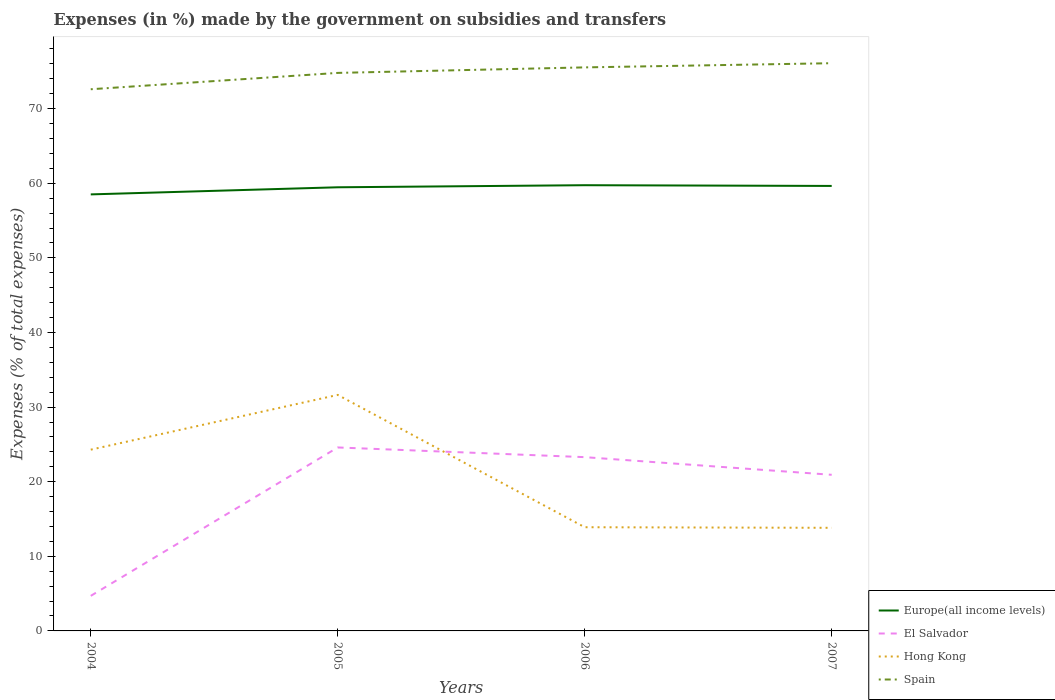How many different coloured lines are there?
Your response must be concise. 4. Is the number of lines equal to the number of legend labels?
Ensure brevity in your answer.  Yes. Across all years, what is the maximum percentage of expenses made by the government on subsidies and transfers in Spain?
Make the answer very short. 72.6. In which year was the percentage of expenses made by the government on subsidies and transfers in Spain maximum?
Your answer should be compact. 2004. What is the total percentage of expenses made by the government on subsidies and transfers in Europe(all income levels) in the graph?
Your answer should be very brief. -1.23. What is the difference between the highest and the second highest percentage of expenses made by the government on subsidies and transfers in Hong Kong?
Your answer should be very brief. 17.81. What is the difference between the highest and the lowest percentage of expenses made by the government on subsidies and transfers in Europe(all income levels)?
Your answer should be compact. 3. Is the percentage of expenses made by the government on subsidies and transfers in Spain strictly greater than the percentage of expenses made by the government on subsidies and transfers in El Salvador over the years?
Keep it short and to the point. No. How many lines are there?
Ensure brevity in your answer.  4. How many years are there in the graph?
Offer a terse response. 4. Are the values on the major ticks of Y-axis written in scientific E-notation?
Your answer should be compact. No. Does the graph contain grids?
Offer a very short reply. No. Where does the legend appear in the graph?
Your response must be concise. Bottom right. How many legend labels are there?
Provide a succinct answer. 4. How are the legend labels stacked?
Keep it short and to the point. Vertical. What is the title of the graph?
Ensure brevity in your answer.  Expenses (in %) made by the government on subsidies and transfers. What is the label or title of the X-axis?
Keep it short and to the point. Years. What is the label or title of the Y-axis?
Offer a terse response. Expenses (% of total expenses). What is the Expenses (% of total expenses) in Europe(all income levels) in 2004?
Your response must be concise. 58.5. What is the Expenses (% of total expenses) in El Salvador in 2004?
Ensure brevity in your answer.  4.7. What is the Expenses (% of total expenses) in Hong Kong in 2004?
Ensure brevity in your answer.  24.29. What is the Expenses (% of total expenses) in Spain in 2004?
Make the answer very short. 72.6. What is the Expenses (% of total expenses) in Europe(all income levels) in 2005?
Provide a succinct answer. 59.46. What is the Expenses (% of total expenses) in El Salvador in 2005?
Give a very brief answer. 24.59. What is the Expenses (% of total expenses) in Hong Kong in 2005?
Your answer should be compact. 31.63. What is the Expenses (% of total expenses) in Spain in 2005?
Provide a succinct answer. 74.79. What is the Expenses (% of total expenses) in Europe(all income levels) in 2006?
Your answer should be very brief. 59.74. What is the Expenses (% of total expenses) of El Salvador in 2006?
Provide a short and direct response. 23.29. What is the Expenses (% of total expenses) in Hong Kong in 2006?
Give a very brief answer. 13.9. What is the Expenses (% of total expenses) in Spain in 2006?
Ensure brevity in your answer.  75.53. What is the Expenses (% of total expenses) of Europe(all income levels) in 2007?
Provide a short and direct response. 59.64. What is the Expenses (% of total expenses) of El Salvador in 2007?
Your answer should be compact. 20.92. What is the Expenses (% of total expenses) in Hong Kong in 2007?
Your answer should be compact. 13.82. What is the Expenses (% of total expenses) of Spain in 2007?
Give a very brief answer. 76.09. Across all years, what is the maximum Expenses (% of total expenses) of Europe(all income levels)?
Keep it short and to the point. 59.74. Across all years, what is the maximum Expenses (% of total expenses) of El Salvador?
Provide a succinct answer. 24.59. Across all years, what is the maximum Expenses (% of total expenses) of Hong Kong?
Give a very brief answer. 31.63. Across all years, what is the maximum Expenses (% of total expenses) in Spain?
Ensure brevity in your answer.  76.09. Across all years, what is the minimum Expenses (% of total expenses) of Europe(all income levels)?
Your answer should be compact. 58.5. Across all years, what is the minimum Expenses (% of total expenses) of El Salvador?
Provide a succinct answer. 4.7. Across all years, what is the minimum Expenses (% of total expenses) of Hong Kong?
Ensure brevity in your answer.  13.82. Across all years, what is the minimum Expenses (% of total expenses) of Spain?
Your response must be concise. 72.6. What is the total Expenses (% of total expenses) in Europe(all income levels) in the graph?
Make the answer very short. 237.34. What is the total Expenses (% of total expenses) in El Salvador in the graph?
Your answer should be very brief. 73.5. What is the total Expenses (% of total expenses) of Hong Kong in the graph?
Offer a very short reply. 83.64. What is the total Expenses (% of total expenses) of Spain in the graph?
Make the answer very short. 299. What is the difference between the Expenses (% of total expenses) in Europe(all income levels) in 2004 and that in 2005?
Make the answer very short. -0.95. What is the difference between the Expenses (% of total expenses) in El Salvador in 2004 and that in 2005?
Ensure brevity in your answer.  -19.89. What is the difference between the Expenses (% of total expenses) of Hong Kong in 2004 and that in 2005?
Your response must be concise. -7.34. What is the difference between the Expenses (% of total expenses) in Spain in 2004 and that in 2005?
Offer a very short reply. -2.19. What is the difference between the Expenses (% of total expenses) of Europe(all income levels) in 2004 and that in 2006?
Your answer should be compact. -1.23. What is the difference between the Expenses (% of total expenses) in El Salvador in 2004 and that in 2006?
Make the answer very short. -18.59. What is the difference between the Expenses (% of total expenses) in Hong Kong in 2004 and that in 2006?
Offer a very short reply. 10.39. What is the difference between the Expenses (% of total expenses) in Spain in 2004 and that in 2006?
Offer a very short reply. -2.93. What is the difference between the Expenses (% of total expenses) of Europe(all income levels) in 2004 and that in 2007?
Your response must be concise. -1.13. What is the difference between the Expenses (% of total expenses) of El Salvador in 2004 and that in 2007?
Give a very brief answer. -16.23. What is the difference between the Expenses (% of total expenses) in Hong Kong in 2004 and that in 2007?
Keep it short and to the point. 10.47. What is the difference between the Expenses (% of total expenses) of Spain in 2004 and that in 2007?
Your response must be concise. -3.49. What is the difference between the Expenses (% of total expenses) of Europe(all income levels) in 2005 and that in 2006?
Your answer should be very brief. -0.28. What is the difference between the Expenses (% of total expenses) of El Salvador in 2005 and that in 2006?
Your response must be concise. 1.3. What is the difference between the Expenses (% of total expenses) of Hong Kong in 2005 and that in 2006?
Your answer should be compact. 17.73. What is the difference between the Expenses (% of total expenses) of Spain in 2005 and that in 2006?
Provide a succinct answer. -0.74. What is the difference between the Expenses (% of total expenses) of Europe(all income levels) in 2005 and that in 2007?
Provide a short and direct response. -0.18. What is the difference between the Expenses (% of total expenses) of El Salvador in 2005 and that in 2007?
Your answer should be very brief. 3.67. What is the difference between the Expenses (% of total expenses) of Hong Kong in 2005 and that in 2007?
Give a very brief answer. 17.81. What is the difference between the Expenses (% of total expenses) of Spain in 2005 and that in 2007?
Offer a terse response. -1.3. What is the difference between the Expenses (% of total expenses) in Europe(all income levels) in 2006 and that in 2007?
Give a very brief answer. 0.1. What is the difference between the Expenses (% of total expenses) in El Salvador in 2006 and that in 2007?
Offer a very short reply. 2.37. What is the difference between the Expenses (% of total expenses) of Hong Kong in 2006 and that in 2007?
Offer a terse response. 0.08. What is the difference between the Expenses (% of total expenses) of Spain in 2006 and that in 2007?
Your answer should be very brief. -0.56. What is the difference between the Expenses (% of total expenses) in Europe(all income levels) in 2004 and the Expenses (% of total expenses) in El Salvador in 2005?
Give a very brief answer. 33.92. What is the difference between the Expenses (% of total expenses) of Europe(all income levels) in 2004 and the Expenses (% of total expenses) of Hong Kong in 2005?
Offer a very short reply. 26.87. What is the difference between the Expenses (% of total expenses) in Europe(all income levels) in 2004 and the Expenses (% of total expenses) in Spain in 2005?
Your answer should be compact. -16.28. What is the difference between the Expenses (% of total expenses) in El Salvador in 2004 and the Expenses (% of total expenses) in Hong Kong in 2005?
Provide a short and direct response. -26.93. What is the difference between the Expenses (% of total expenses) in El Salvador in 2004 and the Expenses (% of total expenses) in Spain in 2005?
Provide a short and direct response. -70.09. What is the difference between the Expenses (% of total expenses) of Hong Kong in 2004 and the Expenses (% of total expenses) of Spain in 2005?
Give a very brief answer. -50.5. What is the difference between the Expenses (% of total expenses) of Europe(all income levels) in 2004 and the Expenses (% of total expenses) of El Salvador in 2006?
Ensure brevity in your answer.  35.21. What is the difference between the Expenses (% of total expenses) in Europe(all income levels) in 2004 and the Expenses (% of total expenses) in Hong Kong in 2006?
Your response must be concise. 44.61. What is the difference between the Expenses (% of total expenses) of Europe(all income levels) in 2004 and the Expenses (% of total expenses) of Spain in 2006?
Keep it short and to the point. -17.02. What is the difference between the Expenses (% of total expenses) of El Salvador in 2004 and the Expenses (% of total expenses) of Spain in 2006?
Provide a succinct answer. -70.83. What is the difference between the Expenses (% of total expenses) in Hong Kong in 2004 and the Expenses (% of total expenses) in Spain in 2006?
Ensure brevity in your answer.  -51.23. What is the difference between the Expenses (% of total expenses) in Europe(all income levels) in 2004 and the Expenses (% of total expenses) in El Salvador in 2007?
Your answer should be compact. 37.58. What is the difference between the Expenses (% of total expenses) in Europe(all income levels) in 2004 and the Expenses (% of total expenses) in Hong Kong in 2007?
Your answer should be very brief. 44.68. What is the difference between the Expenses (% of total expenses) of Europe(all income levels) in 2004 and the Expenses (% of total expenses) of Spain in 2007?
Ensure brevity in your answer.  -17.58. What is the difference between the Expenses (% of total expenses) of El Salvador in 2004 and the Expenses (% of total expenses) of Hong Kong in 2007?
Your answer should be compact. -9.12. What is the difference between the Expenses (% of total expenses) of El Salvador in 2004 and the Expenses (% of total expenses) of Spain in 2007?
Your response must be concise. -71.39. What is the difference between the Expenses (% of total expenses) in Hong Kong in 2004 and the Expenses (% of total expenses) in Spain in 2007?
Make the answer very short. -51.79. What is the difference between the Expenses (% of total expenses) of Europe(all income levels) in 2005 and the Expenses (% of total expenses) of El Salvador in 2006?
Your answer should be compact. 36.17. What is the difference between the Expenses (% of total expenses) in Europe(all income levels) in 2005 and the Expenses (% of total expenses) in Hong Kong in 2006?
Provide a succinct answer. 45.56. What is the difference between the Expenses (% of total expenses) of Europe(all income levels) in 2005 and the Expenses (% of total expenses) of Spain in 2006?
Your response must be concise. -16.07. What is the difference between the Expenses (% of total expenses) in El Salvador in 2005 and the Expenses (% of total expenses) in Hong Kong in 2006?
Your response must be concise. 10.69. What is the difference between the Expenses (% of total expenses) in El Salvador in 2005 and the Expenses (% of total expenses) in Spain in 2006?
Give a very brief answer. -50.94. What is the difference between the Expenses (% of total expenses) of Hong Kong in 2005 and the Expenses (% of total expenses) of Spain in 2006?
Your answer should be very brief. -43.9. What is the difference between the Expenses (% of total expenses) in Europe(all income levels) in 2005 and the Expenses (% of total expenses) in El Salvador in 2007?
Provide a succinct answer. 38.53. What is the difference between the Expenses (% of total expenses) of Europe(all income levels) in 2005 and the Expenses (% of total expenses) of Hong Kong in 2007?
Provide a succinct answer. 45.64. What is the difference between the Expenses (% of total expenses) of Europe(all income levels) in 2005 and the Expenses (% of total expenses) of Spain in 2007?
Ensure brevity in your answer.  -16.63. What is the difference between the Expenses (% of total expenses) of El Salvador in 2005 and the Expenses (% of total expenses) of Hong Kong in 2007?
Your answer should be very brief. 10.77. What is the difference between the Expenses (% of total expenses) of El Salvador in 2005 and the Expenses (% of total expenses) of Spain in 2007?
Keep it short and to the point. -51.5. What is the difference between the Expenses (% of total expenses) of Hong Kong in 2005 and the Expenses (% of total expenses) of Spain in 2007?
Provide a succinct answer. -44.46. What is the difference between the Expenses (% of total expenses) in Europe(all income levels) in 2006 and the Expenses (% of total expenses) in El Salvador in 2007?
Offer a very short reply. 38.81. What is the difference between the Expenses (% of total expenses) in Europe(all income levels) in 2006 and the Expenses (% of total expenses) in Hong Kong in 2007?
Provide a succinct answer. 45.92. What is the difference between the Expenses (% of total expenses) of Europe(all income levels) in 2006 and the Expenses (% of total expenses) of Spain in 2007?
Your answer should be compact. -16.35. What is the difference between the Expenses (% of total expenses) of El Salvador in 2006 and the Expenses (% of total expenses) of Hong Kong in 2007?
Ensure brevity in your answer.  9.47. What is the difference between the Expenses (% of total expenses) in El Salvador in 2006 and the Expenses (% of total expenses) in Spain in 2007?
Ensure brevity in your answer.  -52.8. What is the difference between the Expenses (% of total expenses) of Hong Kong in 2006 and the Expenses (% of total expenses) of Spain in 2007?
Keep it short and to the point. -62.19. What is the average Expenses (% of total expenses) of Europe(all income levels) per year?
Your answer should be very brief. 59.33. What is the average Expenses (% of total expenses) of El Salvador per year?
Provide a succinct answer. 18.37. What is the average Expenses (% of total expenses) of Hong Kong per year?
Your response must be concise. 20.91. What is the average Expenses (% of total expenses) in Spain per year?
Make the answer very short. 74.75. In the year 2004, what is the difference between the Expenses (% of total expenses) of Europe(all income levels) and Expenses (% of total expenses) of El Salvador?
Provide a short and direct response. 53.81. In the year 2004, what is the difference between the Expenses (% of total expenses) in Europe(all income levels) and Expenses (% of total expenses) in Hong Kong?
Provide a short and direct response. 34.21. In the year 2004, what is the difference between the Expenses (% of total expenses) of Europe(all income levels) and Expenses (% of total expenses) of Spain?
Your response must be concise. -14.09. In the year 2004, what is the difference between the Expenses (% of total expenses) in El Salvador and Expenses (% of total expenses) in Hong Kong?
Your answer should be compact. -19.59. In the year 2004, what is the difference between the Expenses (% of total expenses) of El Salvador and Expenses (% of total expenses) of Spain?
Your response must be concise. -67.9. In the year 2004, what is the difference between the Expenses (% of total expenses) in Hong Kong and Expenses (% of total expenses) in Spain?
Your answer should be compact. -48.3. In the year 2005, what is the difference between the Expenses (% of total expenses) in Europe(all income levels) and Expenses (% of total expenses) in El Salvador?
Make the answer very short. 34.87. In the year 2005, what is the difference between the Expenses (% of total expenses) of Europe(all income levels) and Expenses (% of total expenses) of Hong Kong?
Keep it short and to the point. 27.83. In the year 2005, what is the difference between the Expenses (% of total expenses) of Europe(all income levels) and Expenses (% of total expenses) of Spain?
Give a very brief answer. -15.33. In the year 2005, what is the difference between the Expenses (% of total expenses) of El Salvador and Expenses (% of total expenses) of Hong Kong?
Make the answer very short. -7.04. In the year 2005, what is the difference between the Expenses (% of total expenses) of El Salvador and Expenses (% of total expenses) of Spain?
Keep it short and to the point. -50.2. In the year 2005, what is the difference between the Expenses (% of total expenses) of Hong Kong and Expenses (% of total expenses) of Spain?
Offer a terse response. -43.16. In the year 2006, what is the difference between the Expenses (% of total expenses) of Europe(all income levels) and Expenses (% of total expenses) of El Salvador?
Make the answer very short. 36.45. In the year 2006, what is the difference between the Expenses (% of total expenses) in Europe(all income levels) and Expenses (% of total expenses) in Hong Kong?
Provide a short and direct response. 45.84. In the year 2006, what is the difference between the Expenses (% of total expenses) of Europe(all income levels) and Expenses (% of total expenses) of Spain?
Make the answer very short. -15.79. In the year 2006, what is the difference between the Expenses (% of total expenses) of El Salvador and Expenses (% of total expenses) of Hong Kong?
Give a very brief answer. 9.39. In the year 2006, what is the difference between the Expenses (% of total expenses) in El Salvador and Expenses (% of total expenses) in Spain?
Your answer should be very brief. -52.24. In the year 2006, what is the difference between the Expenses (% of total expenses) in Hong Kong and Expenses (% of total expenses) in Spain?
Offer a very short reply. -61.63. In the year 2007, what is the difference between the Expenses (% of total expenses) in Europe(all income levels) and Expenses (% of total expenses) in El Salvador?
Offer a terse response. 38.71. In the year 2007, what is the difference between the Expenses (% of total expenses) in Europe(all income levels) and Expenses (% of total expenses) in Hong Kong?
Your answer should be very brief. 45.82. In the year 2007, what is the difference between the Expenses (% of total expenses) of Europe(all income levels) and Expenses (% of total expenses) of Spain?
Offer a terse response. -16.45. In the year 2007, what is the difference between the Expenses (% of total expenses) in El Salvador and Expenses (% of total expenses) in Hong Kong?
Your answer should be very brief. 7.1. In the year 2007, what is the difference between the Expenses (% of total expenses) in El Salvador and Expenses (% of total expenses) in Spain?
Your answer should be very brief. -55.16. In the year 2007, what is the difference between the Expenses (% of total expenses) of Hong Kong and Expenses (% of total expenses) of Spain?
Your answer should be very brief. -62.27. What is the ratio of the Expenses (% of total expenses) of Europe(all income levels) in 2004 to that in 2005?
Keep it short and to the point. 0.98. What is the ratio of the Expenses (% of total expenses) in El Salvador in 2004 to that in 2005?
Your response must be concise. 0.19. What is the ratio of the Expenses (% of total expenses) of Hong Kong in 2004 to that in 2005?
Your answer should be very brief. 0.77. What is the ratio of the Expenses (% of total expenses) of Spain in 2004 to that in 2005?
Provide a succinct answer. 0.97. What is the ratio of the Expenses (% of total expenses) of Europe(all income levels) in 2004 to that in 2006?
Keep it short and to the point. 0.98. What is the ratio of the Expenses (% of total expenses) of El Salvador in 2004 to that in 2006?
Your answer should be compact. 0.2. What is the ratio of the Expenses (% of total expenses) of Hong Kong in 2004 to that in 2006?
Offer a terse response. 1.75. What is the ratio of the Expenses (% of total expenses) in Spain in 2004 to that in 2006?
Offer a very short reply. 0.96. What is the ratio of the Expenses (% of total expenses) of Europe(all income levels) in 2004 to that in 2007?
Your response must be concise. 0.98. What is the ratio of the Expenses (% of total expenses) of El Salvador in 2004 to that in 2007?
Provide a succinct answer. 0.22. What is the ratio of the Expenses (% of total expenses) of Hong Kong in 2004 to that in 2007?
Keep it short and to the point. 1.76. What is the ratio of the Expenses (% of total expenses) in Spain in 2004 to that in 2007?
Your response must be concise. 0.95. What is the ratio of the Expenses (% of total expenses) of Europe(all income levels) in 2005 to that in 2006?
Ensure brevity in your answer.  1. What is the ratio of the Expenses (% of total expenses) in El Salvador in 2005 to that in 2006?
Provide a short and direct response. 1.06. What is the ratio of the Expenses (% of total expenses) of Hong Kong in 2005 to that in 2006?
Offer a terse response. 2.28. What is the ratio of the Expenses (% of total expenses) of Spain in 2005 to that in 2006?
Give a very brief answer. 0.99. What is the ratio of the Expenses (% of total expenses) of Europe(all income levels) in 2005 to that in 2007?
Your answer should be very brief. 1. What is the ratio of the Expenses (% of total expenses) of El Salvador in 2005 to that in 2007?
Make the answer very short. 1.18. What is the ratio of the Expenses (% of total expenses) of Hong Kong in 2005 to that in 2007?
Offer a terse response. 2.29. What is the ratio of the Expenses (% of total expenses) in Spain in 2005 to that in 2007?
Give a very brief answer. 0.98. What is the ratio of the Expenses (% of total expenses) in Europe(all income levels) in 2006 to that in 2007?
Ensure brevity in your answer.  1. What is the ratio of the Expenses (% of total expenses) in El Salvador in 2006 to that in 2007?
Offer a very short reply. 1.11. What is the difference between the highest and the second highest Expenses (% of total expenses) of Europe(all income levels)?
Your response must be concise. 0.1. What is the difference between the highest and the second highest Expenses (% of total expenses) in El Salvador?
Your answer should be very brief. 1.3. What is the difference between the highest and the second highest Expenses (% of total expenses) in Hong Kong?
Give a very brief answer. 7.34. What is the difference between the highest and the second highest Expenses (% of total expenses) of Spain?
Your response must be concise. 0.56. What is the difference between the highest and the lowest Expenses (% of total expenses) in Europe(all income levels)?
Your answer should be very brief. 1.23. What is the difference between the highest and the lowest Expenses (% of total expenses) in El Salvador?
Provide a short and direct response. 19.89. What is the difference between the highest and the lowest Expenses (% of total expenses) of Hong Kong?
Make the answer very short. 17.81. What is the difference between the highest and the lowest Expenses (% of total expenses) of Spain?
Make the answer very short. 3.49. 